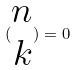<formula> <loc_0><loc_0><loc_500><loc_500>( \begin{matrix} n \\ k \end{matrix} ) = 0</formula> 